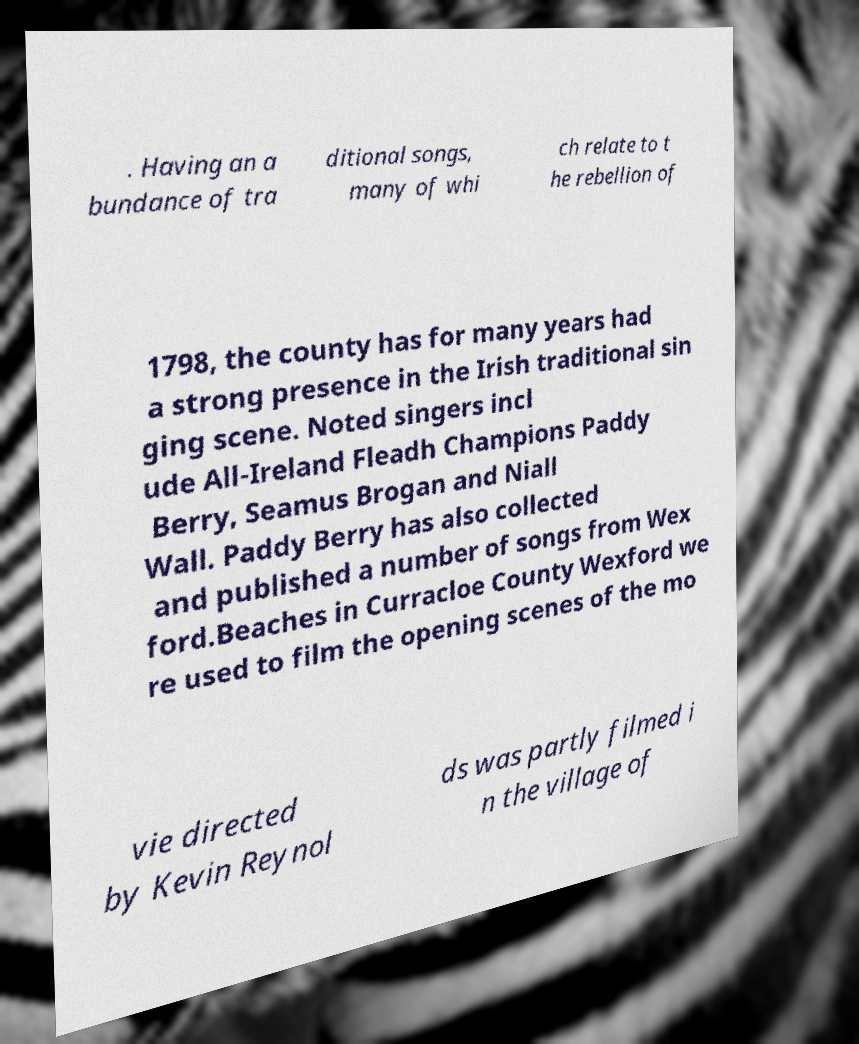For documentation purposes, I need the text within this image transcribed. Could you provide that? . Having an a bundance of tra ditional songs, many of whi ch relate to t he rebellion of 1798, the county has for many years had a strong presence in the Irish traditional sin ging scene. Noted singers incl ude All-Ireland Fleadh Champions Paddy Berry, Seamus Brogan and Niall Wall. Paddy Berry has also collected and published a number of songs from Wex ford.Beaches in Curracloe County Wexford we re used to film the opening scenes of the mo vie directed by Kevin Reynol ds was partly filmed i n the village of 